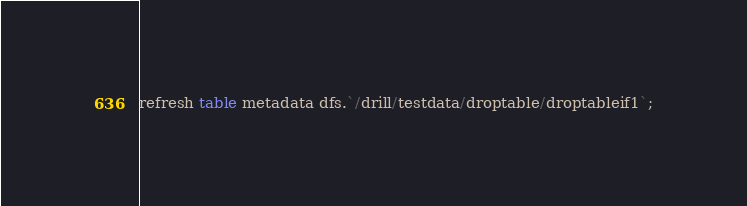Convert code to text. <code><loc_0><loc_0><loc_500><loc_500><_SQL_>refresh table metadata dfs.`/drill/testdata/droptable/droptableif1`;
</code> 